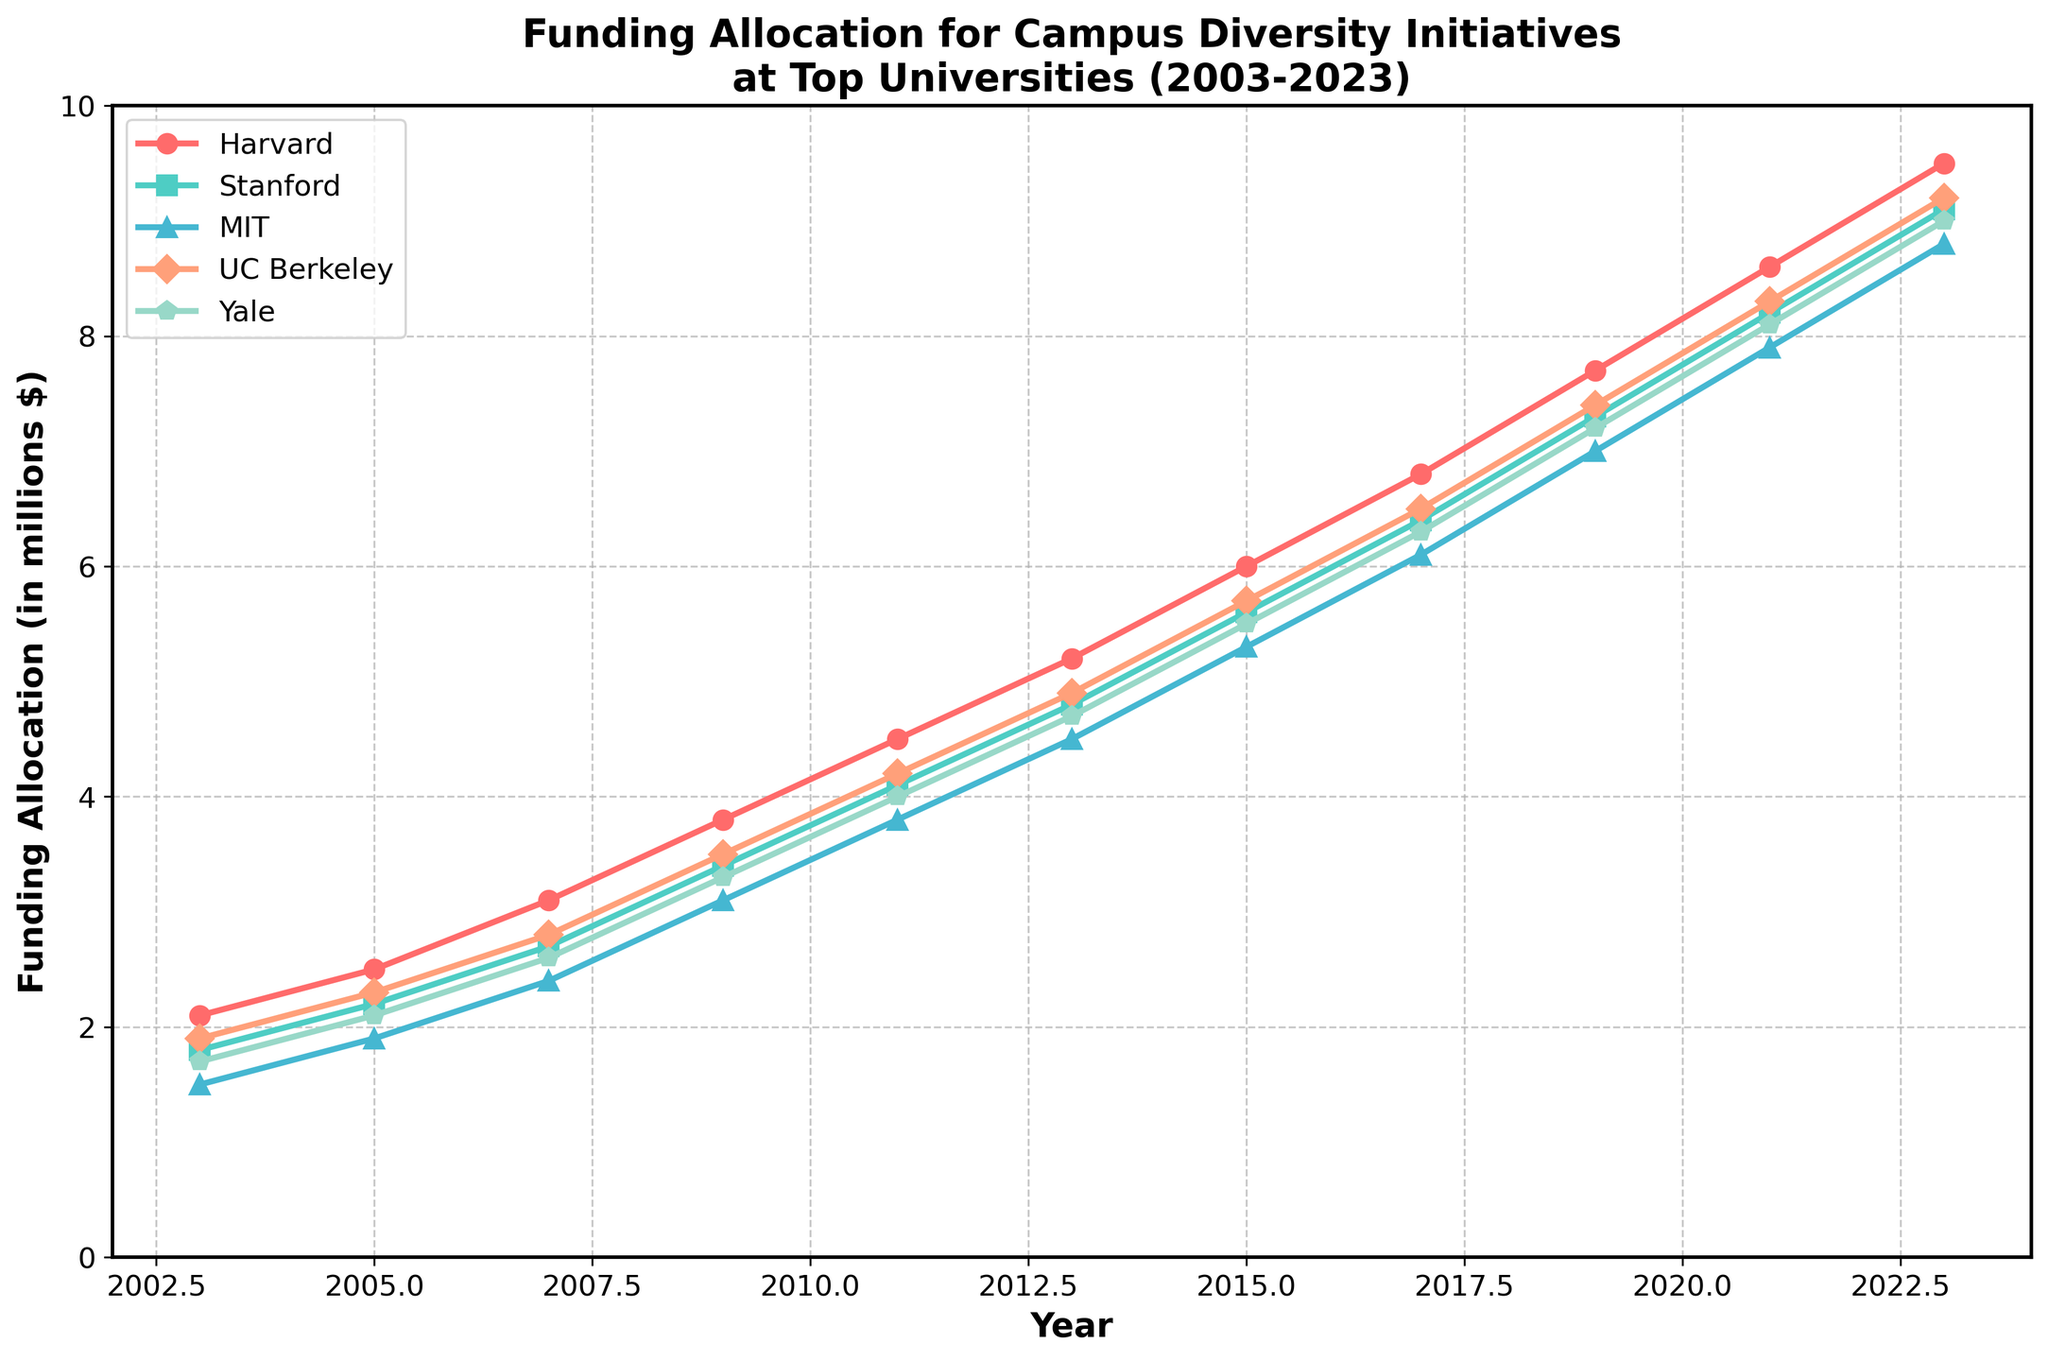who received the highest funding allocation in 2023? By examining the figure, the line that represents Harvard reaches the highest point on the chart in 2023. Thus, Harvard received the highest funding allocation in 2023.
Answer: Harvard What was the funding allocation difference between MIT and UC Berkeley in 2009? In 2009, the funding allocation for MIT was 3.1 million dollars, and for UC Berkeley, it was 3.5 million dollars. The difference would be 3.5 - 3.1 = 0.4 million dollars.
Answer: 0.4 million dollars Which university showed the most consistent growth in funding allocation over the years? The lines for all universities generally moved upward, indicating growth, but Stanford's line appears more steadily inclined without any abrupt changes, showing more consistency.
Answer: Stanford Between 2011 and 2015, which university had the largest increase in funding allocation? In 2011, the figures are Harvard 4.5, Stanford 4.1, MIT 3.8, UC Berkeley 4.2, Yale 4.0. For 2015, the values are Harvard 6.0, Stanford 5.6, MIT 5.3, UC Berkeley 5.7, Yale 5.5. Calculating the increases: Harvard (1.5), Stanford (1.5), MIT (1.5), UC Berkeley (1.5), Yale (1.5). Therefore, all universities had the same level of increase, which is 1.5.
Answer: All the same By how much did Yale's funding allocation increase from 2003 to 2013? Yale’s funding allocation increased from 1.7 million dollars in 2003 to 4.7 million dollars in 2013. The increase would be 4.7 - 1.7 = 3.0 million dollars.
Answer: 3.0 million dollars Which university’s funding allocation increased the fastest between 2019 and 2023? Comparing the allocation values: Harvard (7.7 to 9.5 = 1.8 million), Stanford (7.3 to 9.1 = 1.8 million), MIT (7.0 to 8.8 = 1.8 million), UC Berkeley (7.4 to 9.2 = 1.8 million), Yale (7.2 to 9.0 = 1.8 million). Therefore, all universities increased their funding by 1.8 million, so the rates are the same.
Answer: All the same Out of the five universities, which one had the lowest funding allocation in 2003 and 2023? In 2003, MIT had the lowest funding allocation at 1.5 million dollars. In 2023, MIT also had the lowest funding allocation at 8.8 million dollars.
Answer: MIT What is the average funding allocation for Stanford from 2003 to 2023? Adding Stanford's annual funding allocations: 1.8 + 2.2 + 2.7 + 3.4 + 4.1 + 4.8 + 5.6 + 6.4 + 7.3 + 8.2 + 9.1 = 55.6 million. Dividing by the number of years (11), 55.6 / 11 = 5.055 million dollars.
Answer: 5.055 million dollars 